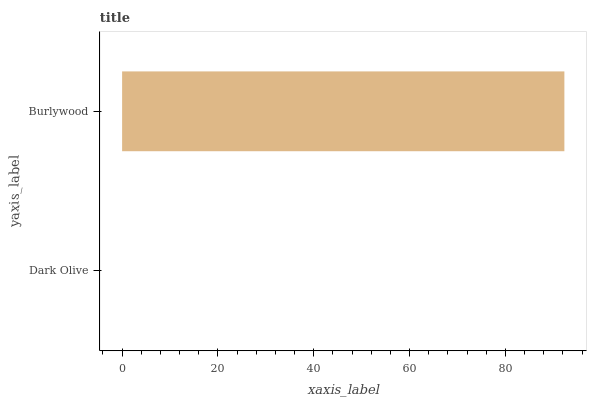Is Dark Olive the minimum?
Answer yes or no. Yes. Is Burlywood the maximum?
Answer yes or no. Yes. Is Burlywood the minimum?
Answer yes or no. No. Is Burlywood greater than Dark Olive?
Answer yes or no. Yes. Is Dark Olive less than Burlywood?
Answer yes or no. Yes. Is Dark Olive greater than Burlywood?
Answer yes or no. No. Is Burlywood less than Dark Olive?
Answer yes or no. No. Is Burlywood the high median?
Answer yes or no. Yes. Is Dark Olive the low median?
Answer yes or no. Yes. Is Dark Olive the high median?
Answer yes or no. No. Is Burlywood the low median?
Answer yes or no. No. 